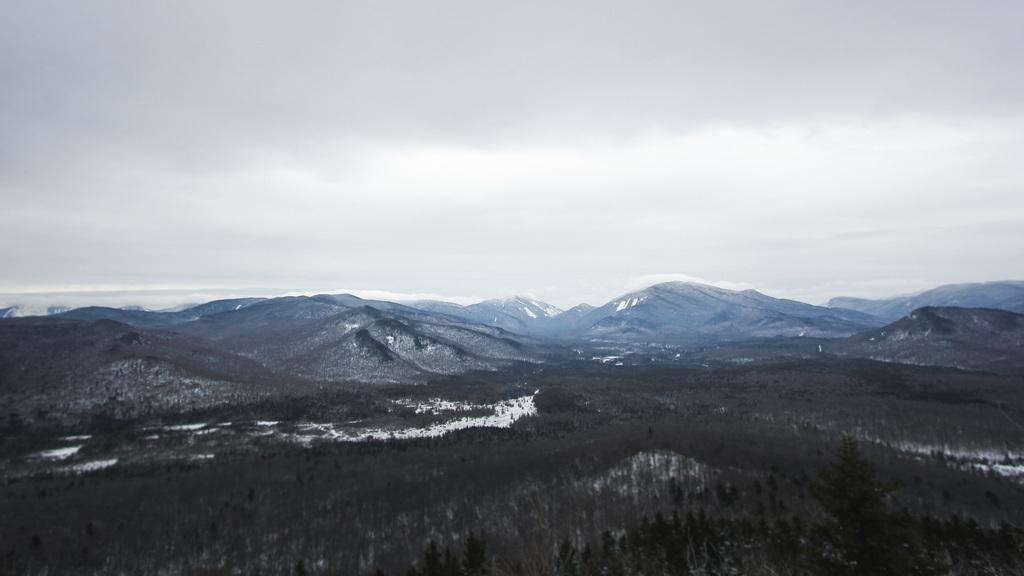What type of natural landscape is depicted in the image? The image features mountains. What other natural elements can be seen in the image? There are trees visible in the image. What is the weather like in the image? The sky is cloudy in the image, and there is snow visible. How many beds are visible in the image? There are no beds present in the image; it features a mountainous landscape with trees and snow. What type of coat is the grandmother wearing in the image? There is no grandmother or coat present in the image. 